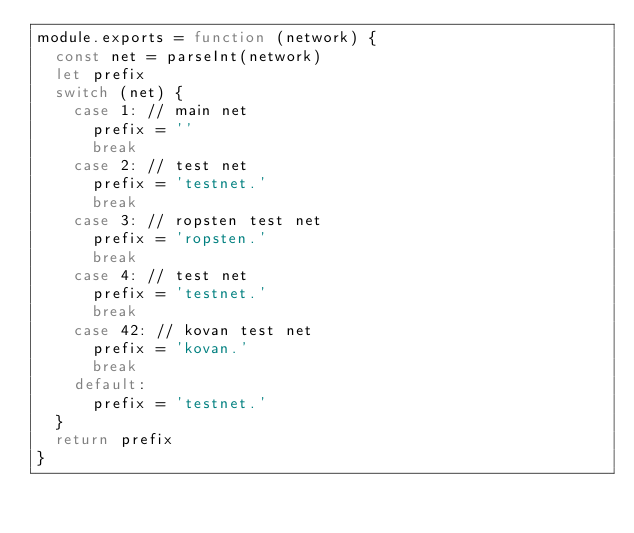Convert code to text. <code><loc_0><loc_0><loc_500><loc_500><_JavaScript_>module.exports = function (network) {
  const net = parseInt(network)
  let prefix
  switch (net) {
    case 1: // main net
      prefix = ''
      break
    case 2: // test net
      prefix = 'testnet.'
      break
    case 3: // ropsten test net
      prefix = 'ropsten.'
      break
    case 4: // test net
      prefix = 'testnet.'
      break
    case 42: // kovan test net
      prefix = 'kovan.'
      break
    default:
      prefix = 'testnet.'
  }
  return prefix
}
</code> 